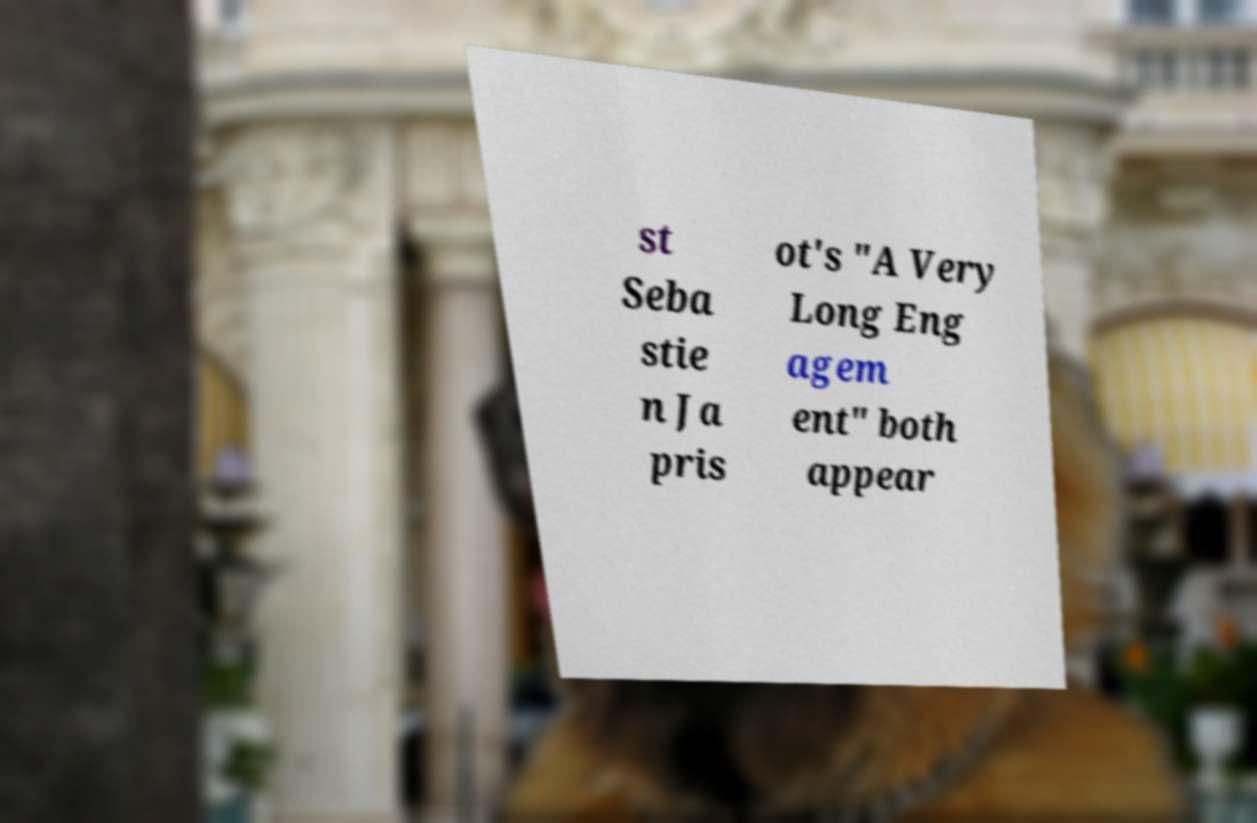I need the written content from this picture converted into text. Can you do that? st Seba stie n Ja pris ot's "A Very Long Eng agem ent" both appear 